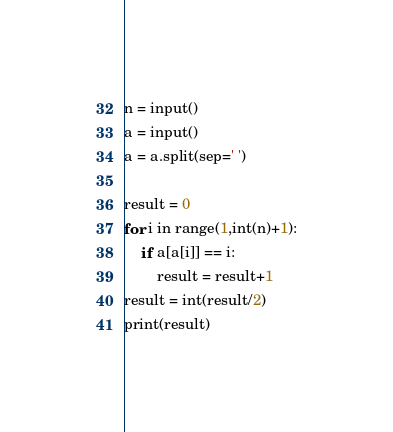<code> <loc_0><loc_0><loc_500><loc_500><_Python_>n = input()
a = input()
a = a.split(sep=' ')

result = 0
for i in range(1,int(n)+1):
    if a[a[i]] == i:
        result = result+1
result = int(result/2)
print(result)</code> 